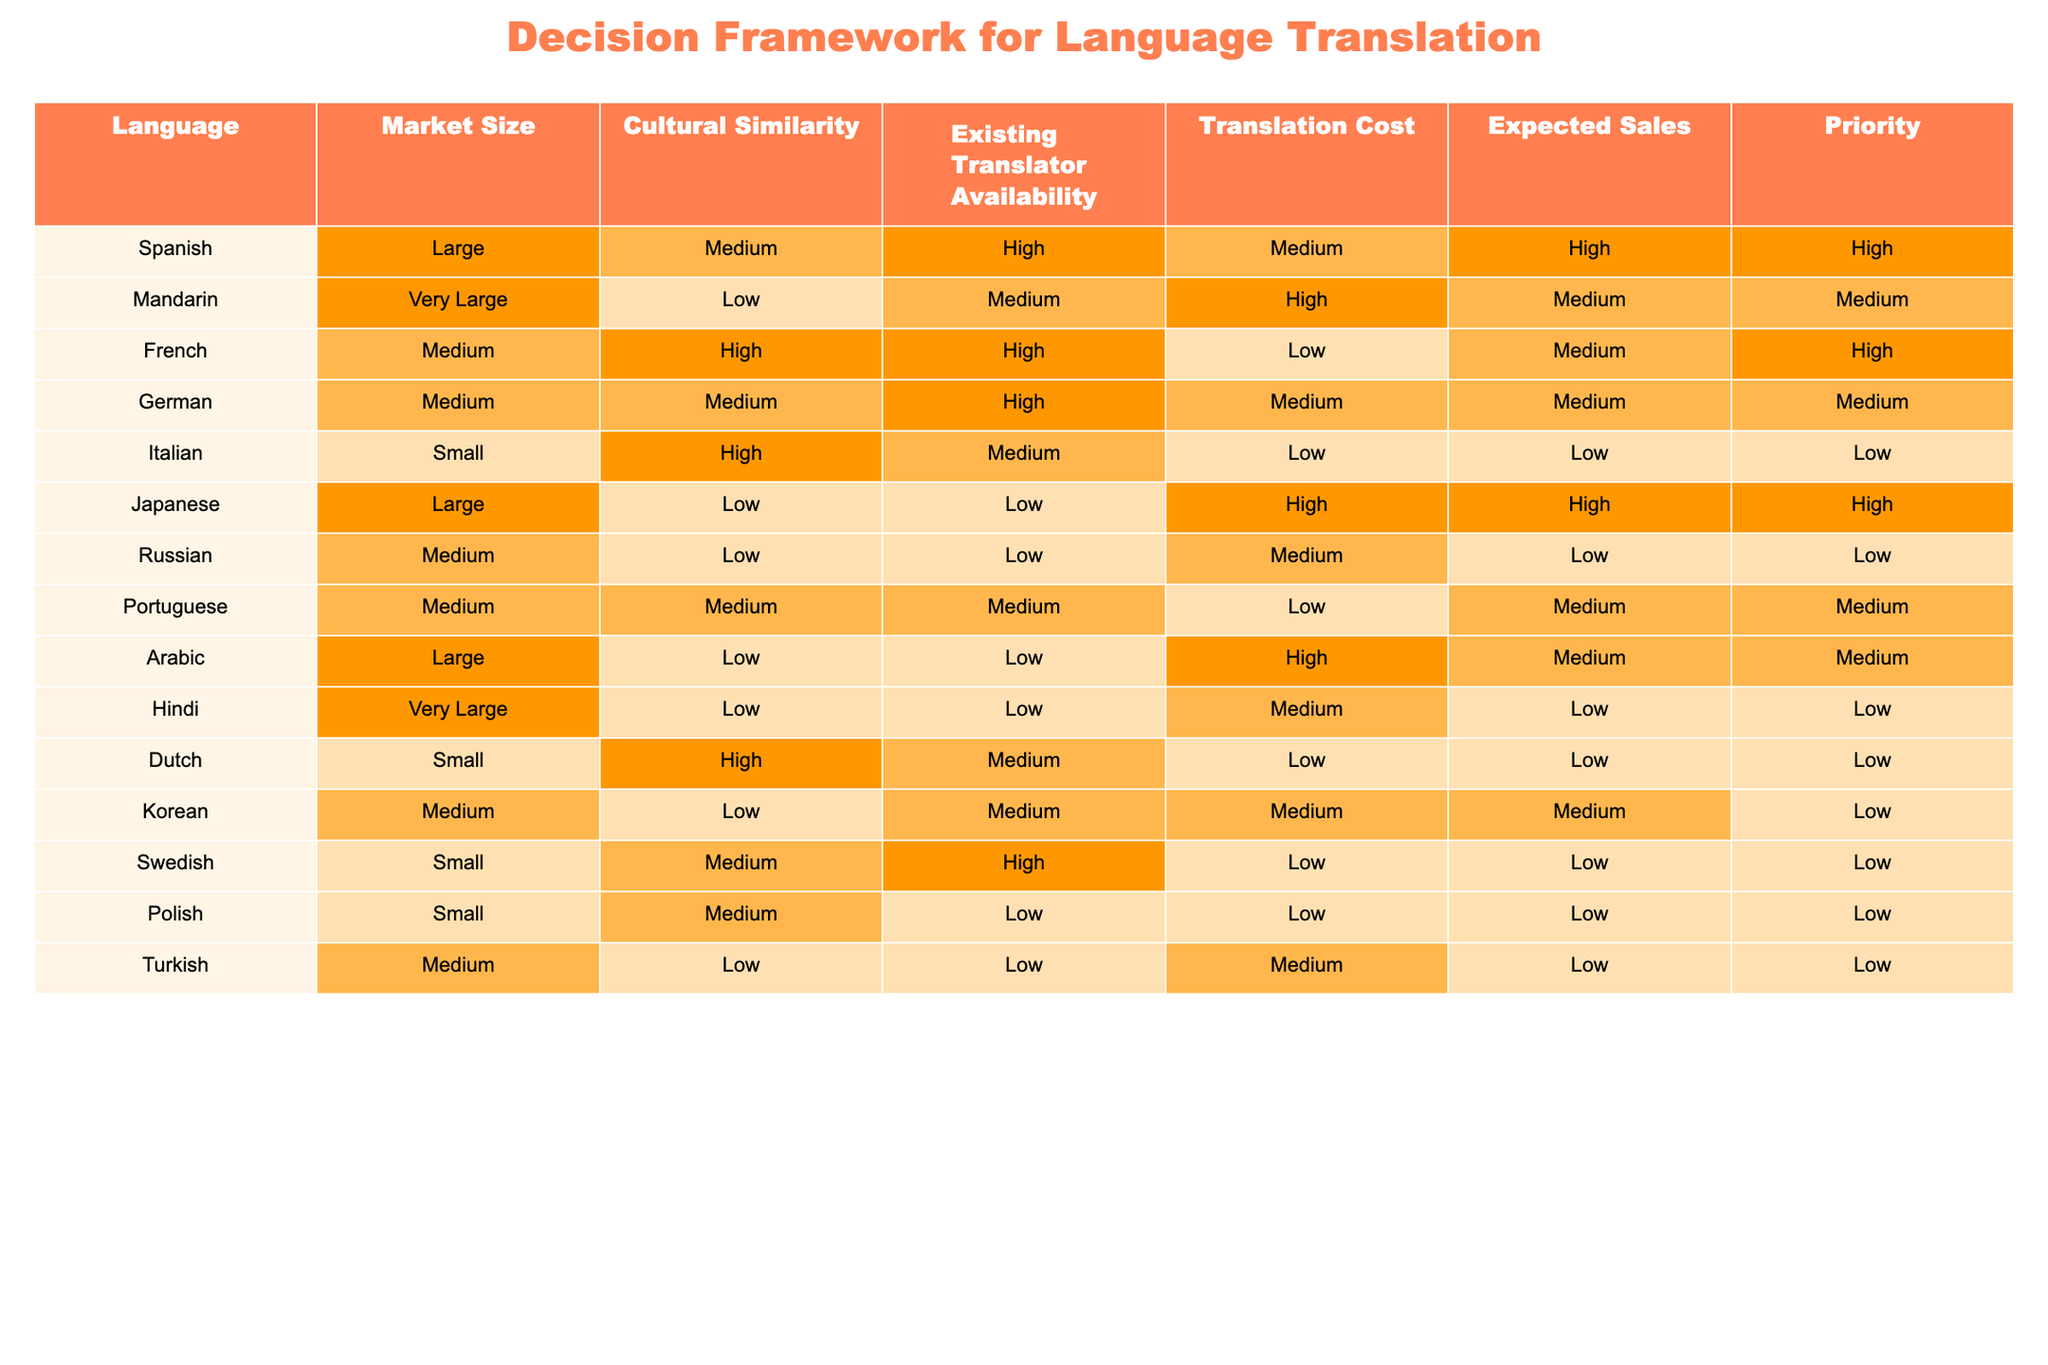What is the market size for French translations? The table indicates that the market size for French translations is categorized as "Medium."
Answer: Medium Which language has the highest cultural similarity? According to the table, Italian and French both have a "High" cultural similarity, but it is essential to note that French has a higher overall priority compared to Italian.
Answer: French Is there a language with high priority and low translation cost? Yes, the table shows that the Spanish translation has a high priority while also having a medium translation cost.
Answer: No How many languages have very large market sizes? The table lists two languages, Hindi and Mandarin, as having a very large market size.
Answer: 2 Which language has the lowest priority and what is its expected sales? The lowest priority is for Italian, which has expected sales categorized as "Low."
Answer: Italian, Low If we consider only high priority languages, which have high existing translator availability? The languages with high priority and high existing translator availability are Spanish and French, as indicated in the respective columns.
Answer: Spanish, French What is the total number of languages categorized as "Medium" in the cultural similarity column? The table shows that there are three languages with "Medium" cultural similarity: Spanish, German, and Portuguese, which sums up to 3.
Answer: 3 Which language has a large market size and low existing translator availability? The language with a large market size but low existing translator availability is Arabic, as specified in the table details.
Answer: Arabic How does the expected sales for Japanese compare to Mandarin? The expected sales for both Japanese and Mandarin are categorized as "Medium," indicating there is no difference between the two in terms of expected sales.
Answer: They are the same 